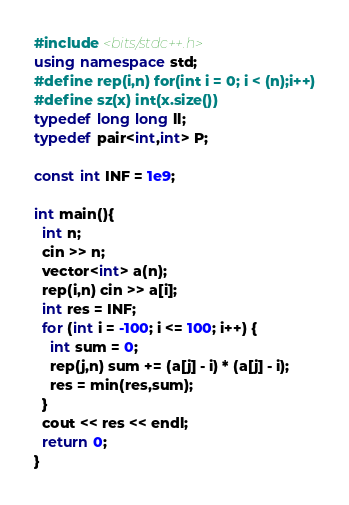Convert code to text. <code><loc_0><loc_0><loc_500><loc_500><_C++_>#include <bits/stdc++.h>
using namespace std;
#define rep(i,n) for(int i = 0; i < (n);i++)
#define sz(x) int(x.size())
typedef long long ll;
typedef pair<int,int> P;

const int INF = 1e9;

int main(){
  int n;
  cin >> n;
  vector<int> a(n);
  rep(i,n) cin >> a[i];
  int res = INF;
  for (int i = -100; i <= 100; i++) {
    int sum = 0;
    rep(j,n) sum += (a[j] - i) * (a[j] - i);
    res = min(res,sum);
  }
  cout << res << endl;
  return 0;
} </code> 